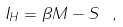Convert formula to latex. <formula><loc_0><loc_0><loc_500><loc_500>I _ { H } = \beta M - S \ ,</formula> 